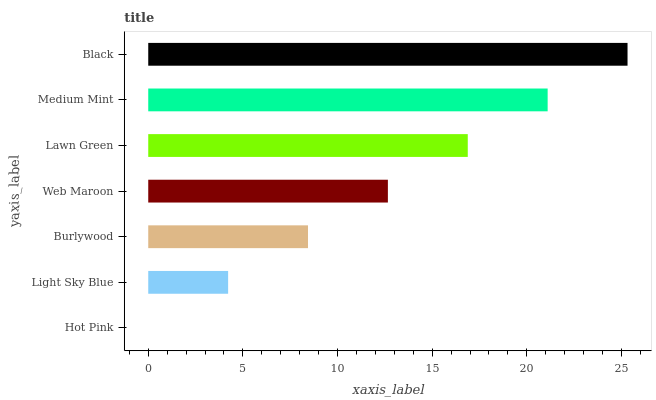Is Hot Pink the minimum?
Answer yes or no. Yes. Is Black the maximum?
Answer yes or no. Yes. Is Light Sky Blue the minimum?
Answer yes or no. No. Is Light Sky Blue the maximum?
Answer yes or no. No. Is Light Sky Blue greater than Hot Pink?
Answer yes or no. Yes. Is Hot Pink less than Light Sky Blue?
Answer yes or no. Yes. Is Hot Pink greater than Light Sky Blue?
Answer yes or no. No. Is Light Sky Blue less than Hot Pink?
Answer yes or no. No. Is Web Maroon the high median?
Answer yes or no. Yes. Is Web Maroon the low median?
Answer yes or no. Yes. Is Black the high median?
Answer yes or no. No. Is Burlywood the low median?
Answer yes or no. No. 